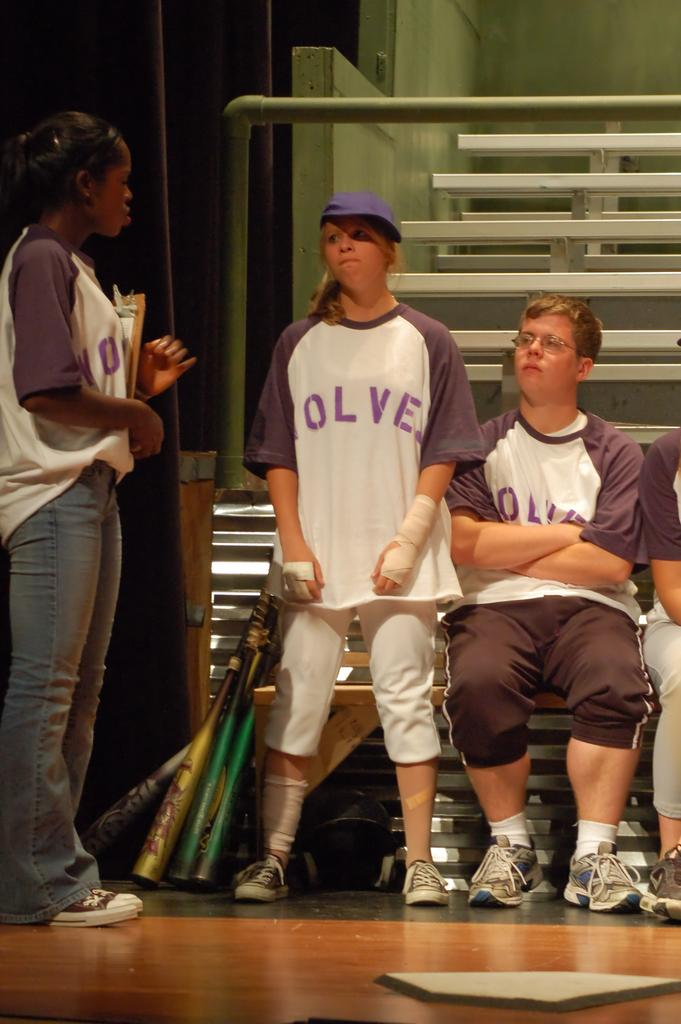Provide a one-sentence caption for the provided image. Girl wearing a shirt which says Wolves standing next to another girl. 